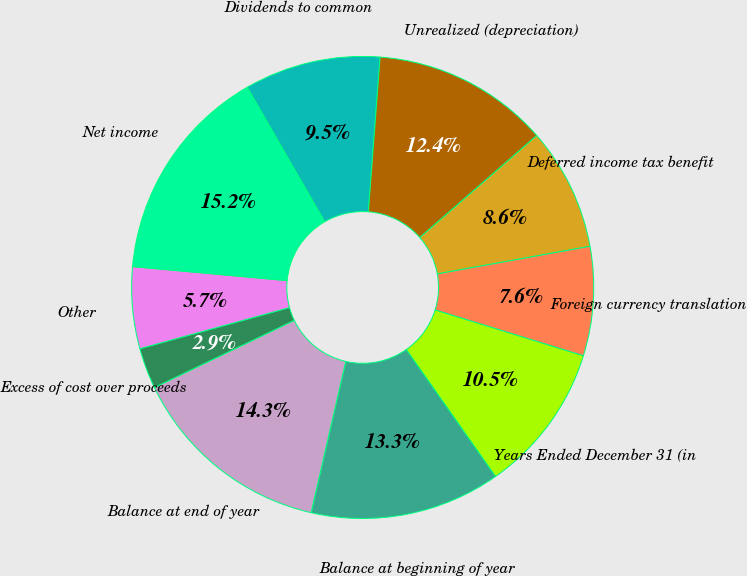<chart> <loc_0><loc_0><loc_500><loc_500><pie_chart><fcel>Years Ended December 31 (in<fcel>Balance at beginning of year<fcel>Balance at end of year<fcel>Excess of cost over proceeds<fcel>Other<fcel>Net income<fcel>Dividends to common<fcel>Unrealized (depreciation)<fcel>Deferred income tax benefit<fcel>Foreign currency translation<nl><fcel>10.48%<fcel>13.33%<fcel>14.29%<fcel>2.86%<fcel>5.71%<fcel>15.24%<fcel>9.52%<fcel>12.38%<fcel>8.57%<fcel>7.62%<nl></chart> 